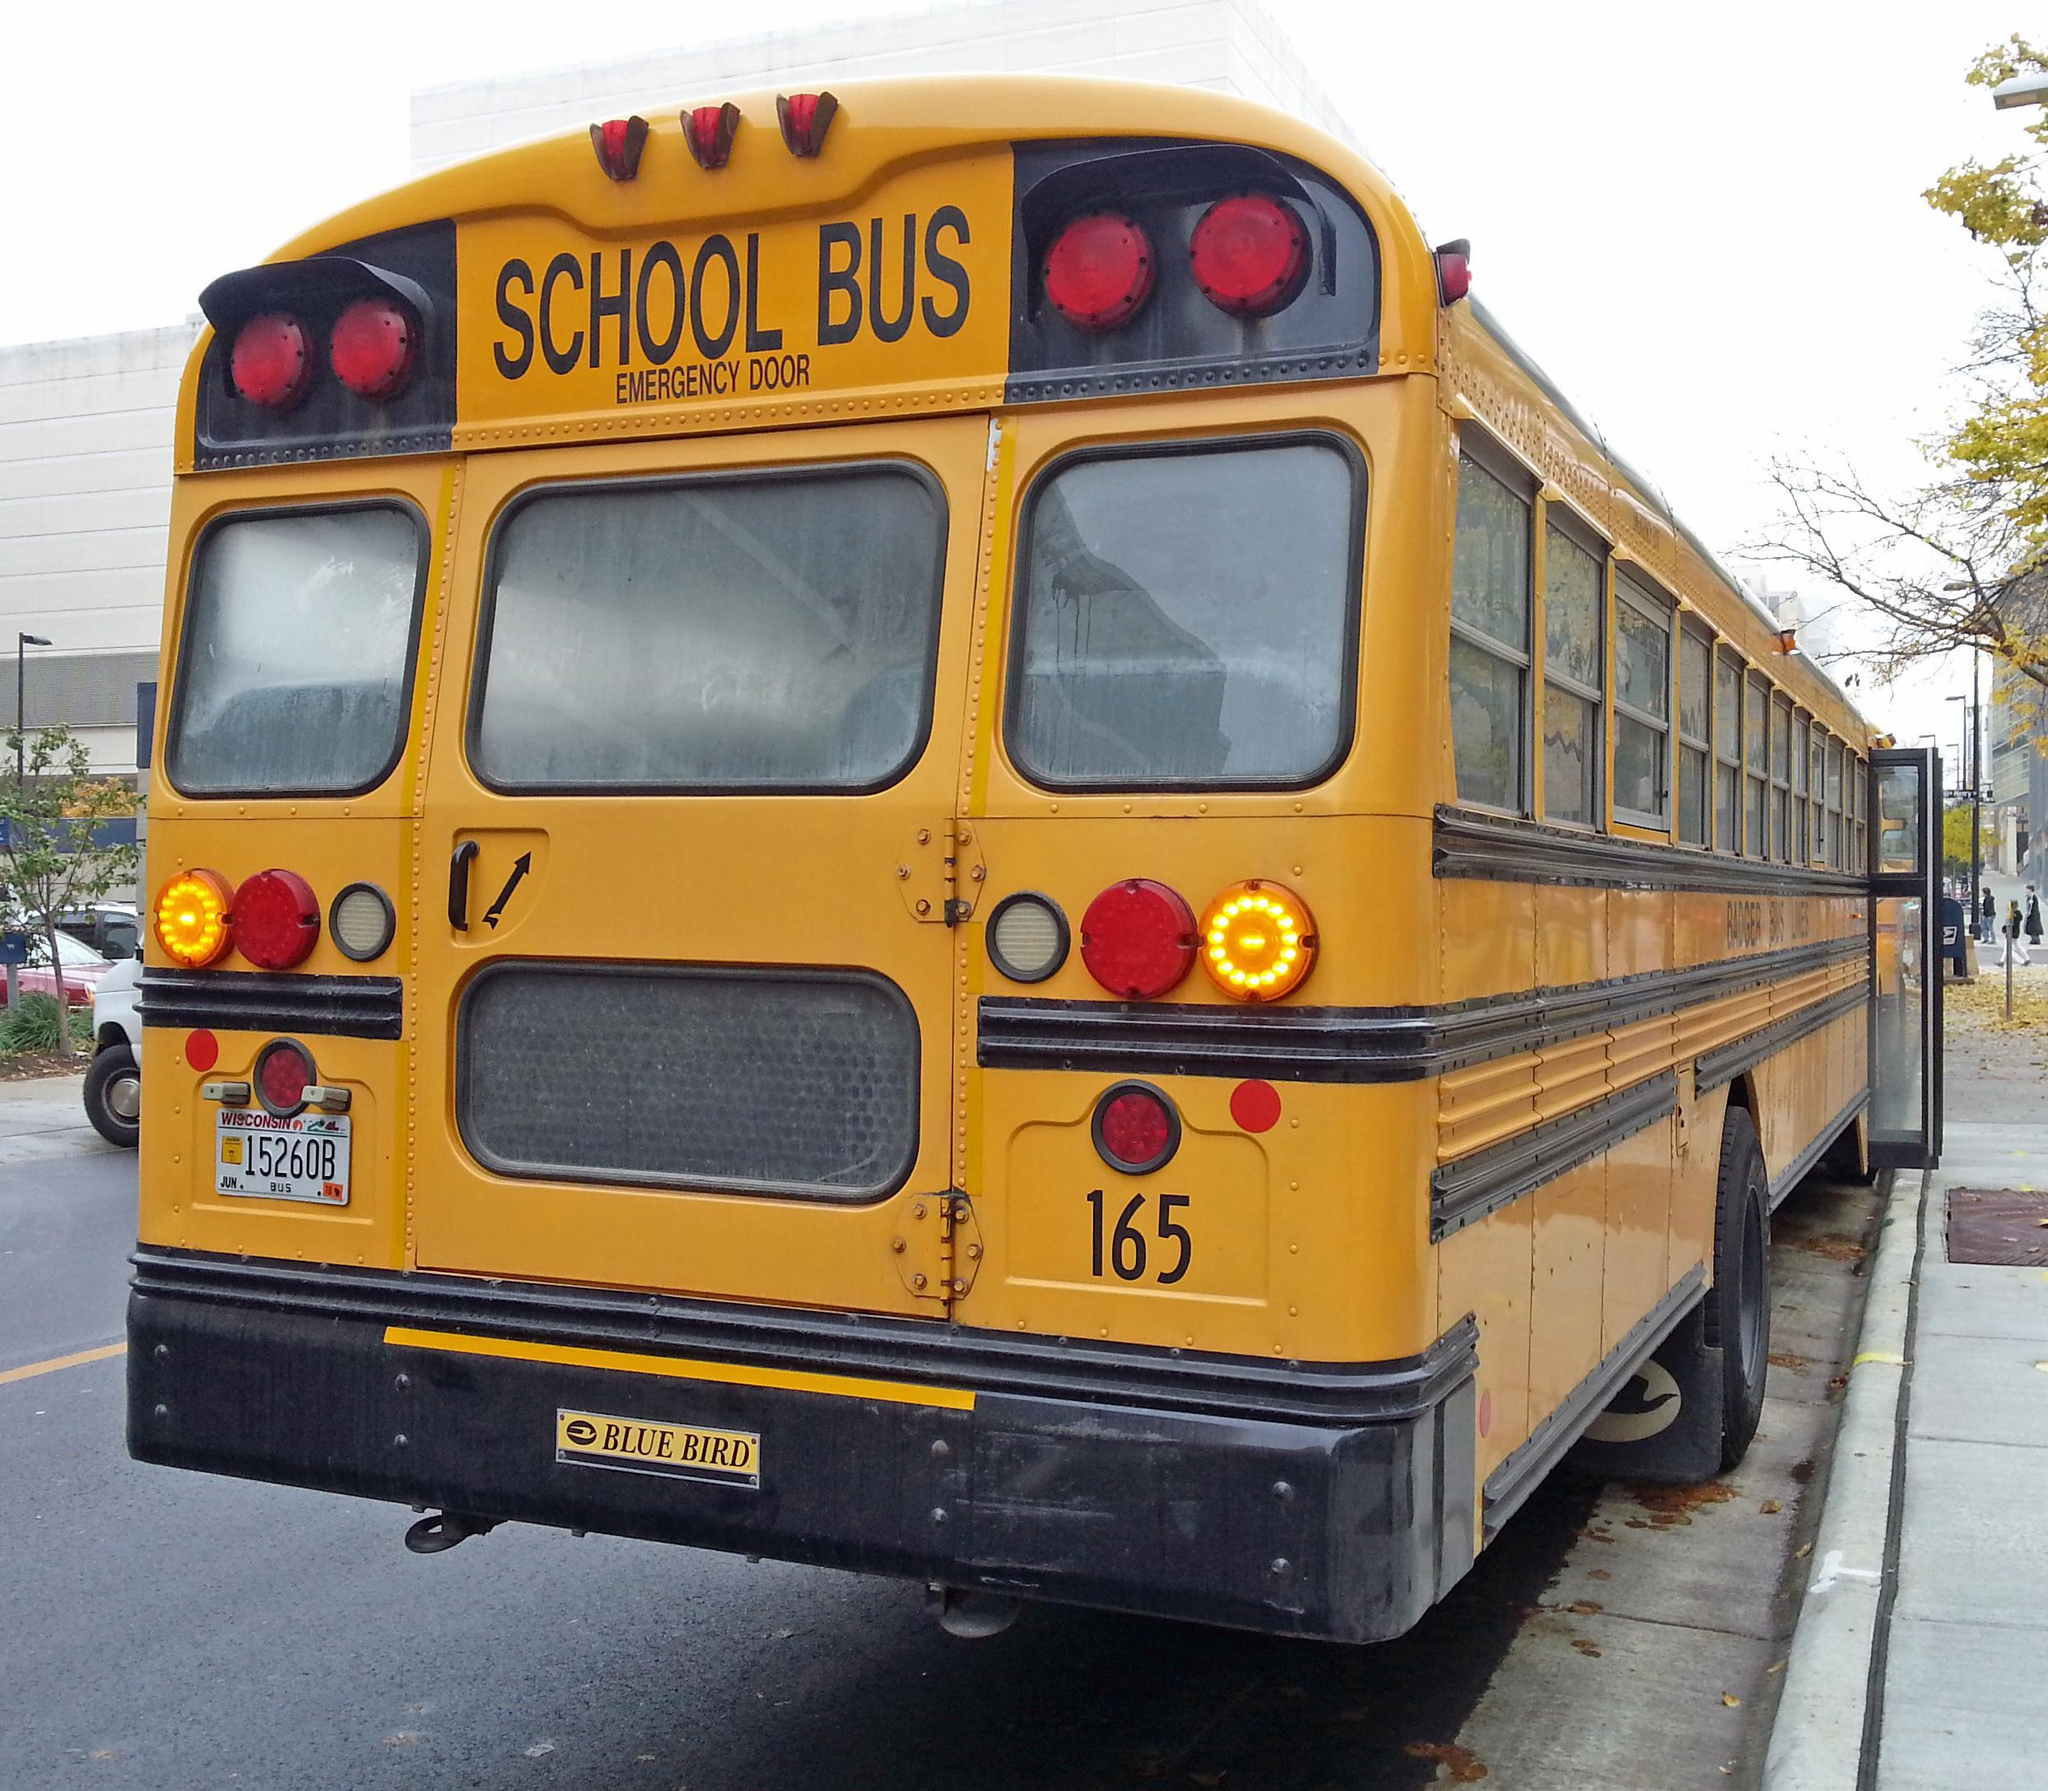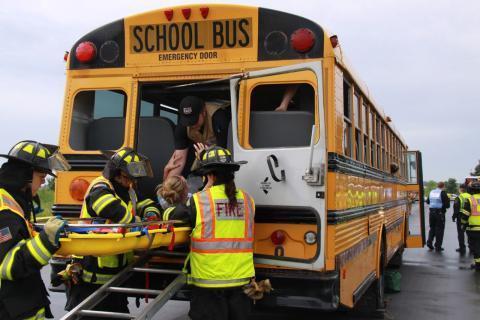The first image is the image on the left, the second image is the image on the right. For the images shown, is this caption "People stand outside the bus in the image on the right." true? Answer yes or no. Yes. The first image is the image on the left, the second image is the image on the right. Analyze the images presented: Is the assertion "At least 2 people are standing on the ground next to the school bus." valid? Answer yes or no. Yes. 